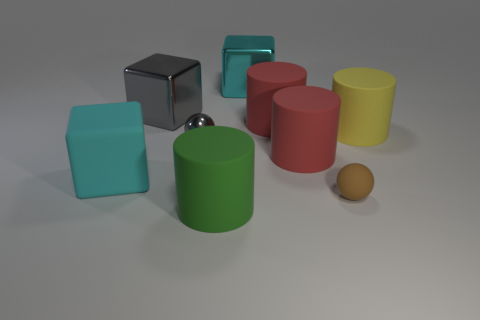Subtract 1 cylinders. How many cylinders are left? 3 Add 1 large yellow rubber objects. How many objects exist? 10 Subtract all blocks. How many objects are left? 6 Add 7 big green matte objects. How many big green matte objects exist? 8 Subtract 1 cyan cubes. How many objects are left? 8 Subtract all blue metal cylinders. Subtract all cyan objects. How many objects are left? 7 Add 1 small brown objects. How many small brown objects are left? 2 